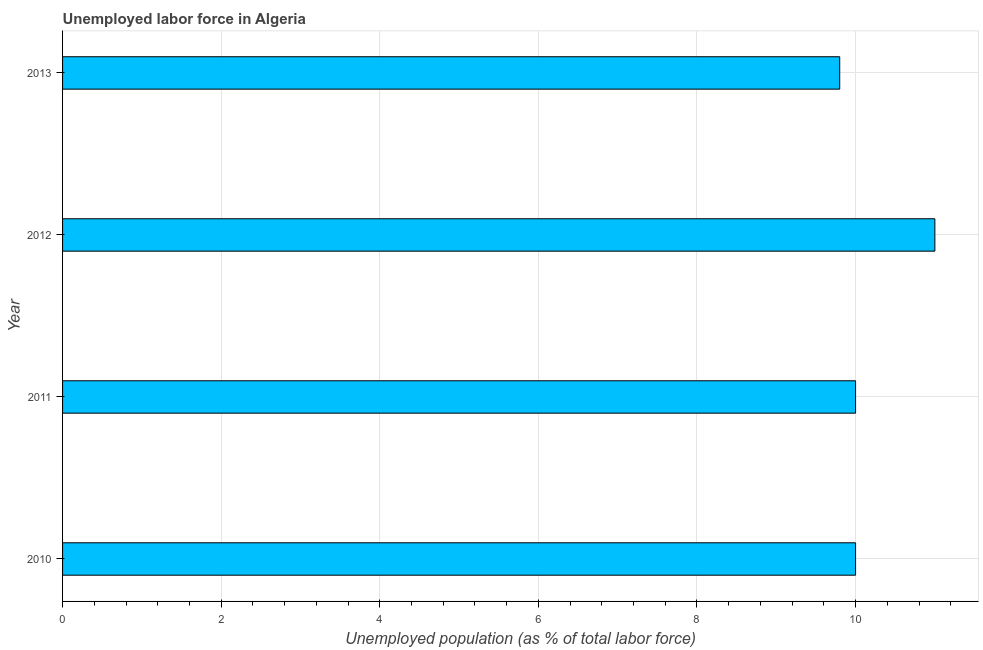What is the title of the graph?
Provide a succinct answer. Unemployed labor force in Algeria. What is the label or title of the X-axis?
Your answer should be very brief. Unemployed population (as % of total labor force). What is the label or title of the Y-axis?
Offer a terse response. Year. Across all years, what is the minimum total unemployed population?
Provide a succinct answer. 9.8. In which year was the total unemployed population maximum?
Make the answer very short. 2012. What is the sum of the total unemployed population?
Make the answer very short. 40.8. What is the average total unemployed population per year?
Offer a terse response. 10.2. In how many years, is the total unemployed population greater than 10 %?
Make the answer very short. 1. Do a majority of the years between 2011 and 2013 (inclusive) have total unemployed population greater than 3.2 %?
Provide a short and direct response. Yes. What is the ratio of the total unemployed population in 2011 to that in 2013?
Your answer should be compact. 1.02. Is the total unemployed population in 2011 less than that in 2013?
Offer a terse response. No. What is the difference between the highest and the second highest total unemployed population?
Your answer should be very brief. 1. Is the sum of the total unemployed population in 2010 and 2011 greater than the maximum total unemployed population across all years?
Make the answer very short. Yes. How many bars are there?
Your answer should be very brief. 4. Are all the bars in the graph horizontal?
Give a very brief answer. Yes. Are the values on the major ticks of X-axis written in scientific E-notation?
Make the answer very short. No. What is the Unemployed population (as % of total labor force) in 2011?
Your answer should be very brief. 10. What is the Unemployed population (as % of total labor force) in 2012?
Provide a short and direct response. 11. What is the Unemployed population (as % of total labor force) of 2013?
Make the answer very short. 9.8. What is the difference between the Unemployed population (as % of total labor force) in 2010 and 2012?
Provide a short and direct response. -1. What is the difference between the Unemployed population (as % of total labor force) in 2010 and 2013?
Ensure brevity in your answer.  0.2. What is the difference between the Unemployed population (as % of total labor force) in 2012 and 2013?
Your response must be concise. 1.2. What is the ratio of the Unemployed population (as % of total labor force) in 2010 to that in 2011?
Your answer should be very brief. 1. What is the ratio of the Unemployed population (as % of total labor force) in 2010 to that in 2012?
Make the answer very short. 0.91. What is the ratio of the Unemployed population (as % of total labor force) in 2010 to that in 2013?
Provide a short and direct response. 1.02. What is the ratio of the Unemployed population (as % of total labor force) in 2011 to that in 2012?
Give a very brief answer. 0.91. What is the ratio of the Unemployed population (as % of total labor force) in 2011 to that in 2013?
Keep it short and to the point. 1.02. What is the ratio of the Unemployed population (as % of total labor force) in 2012 to that in 2013?
Your answer should be very brief. 1.12. 